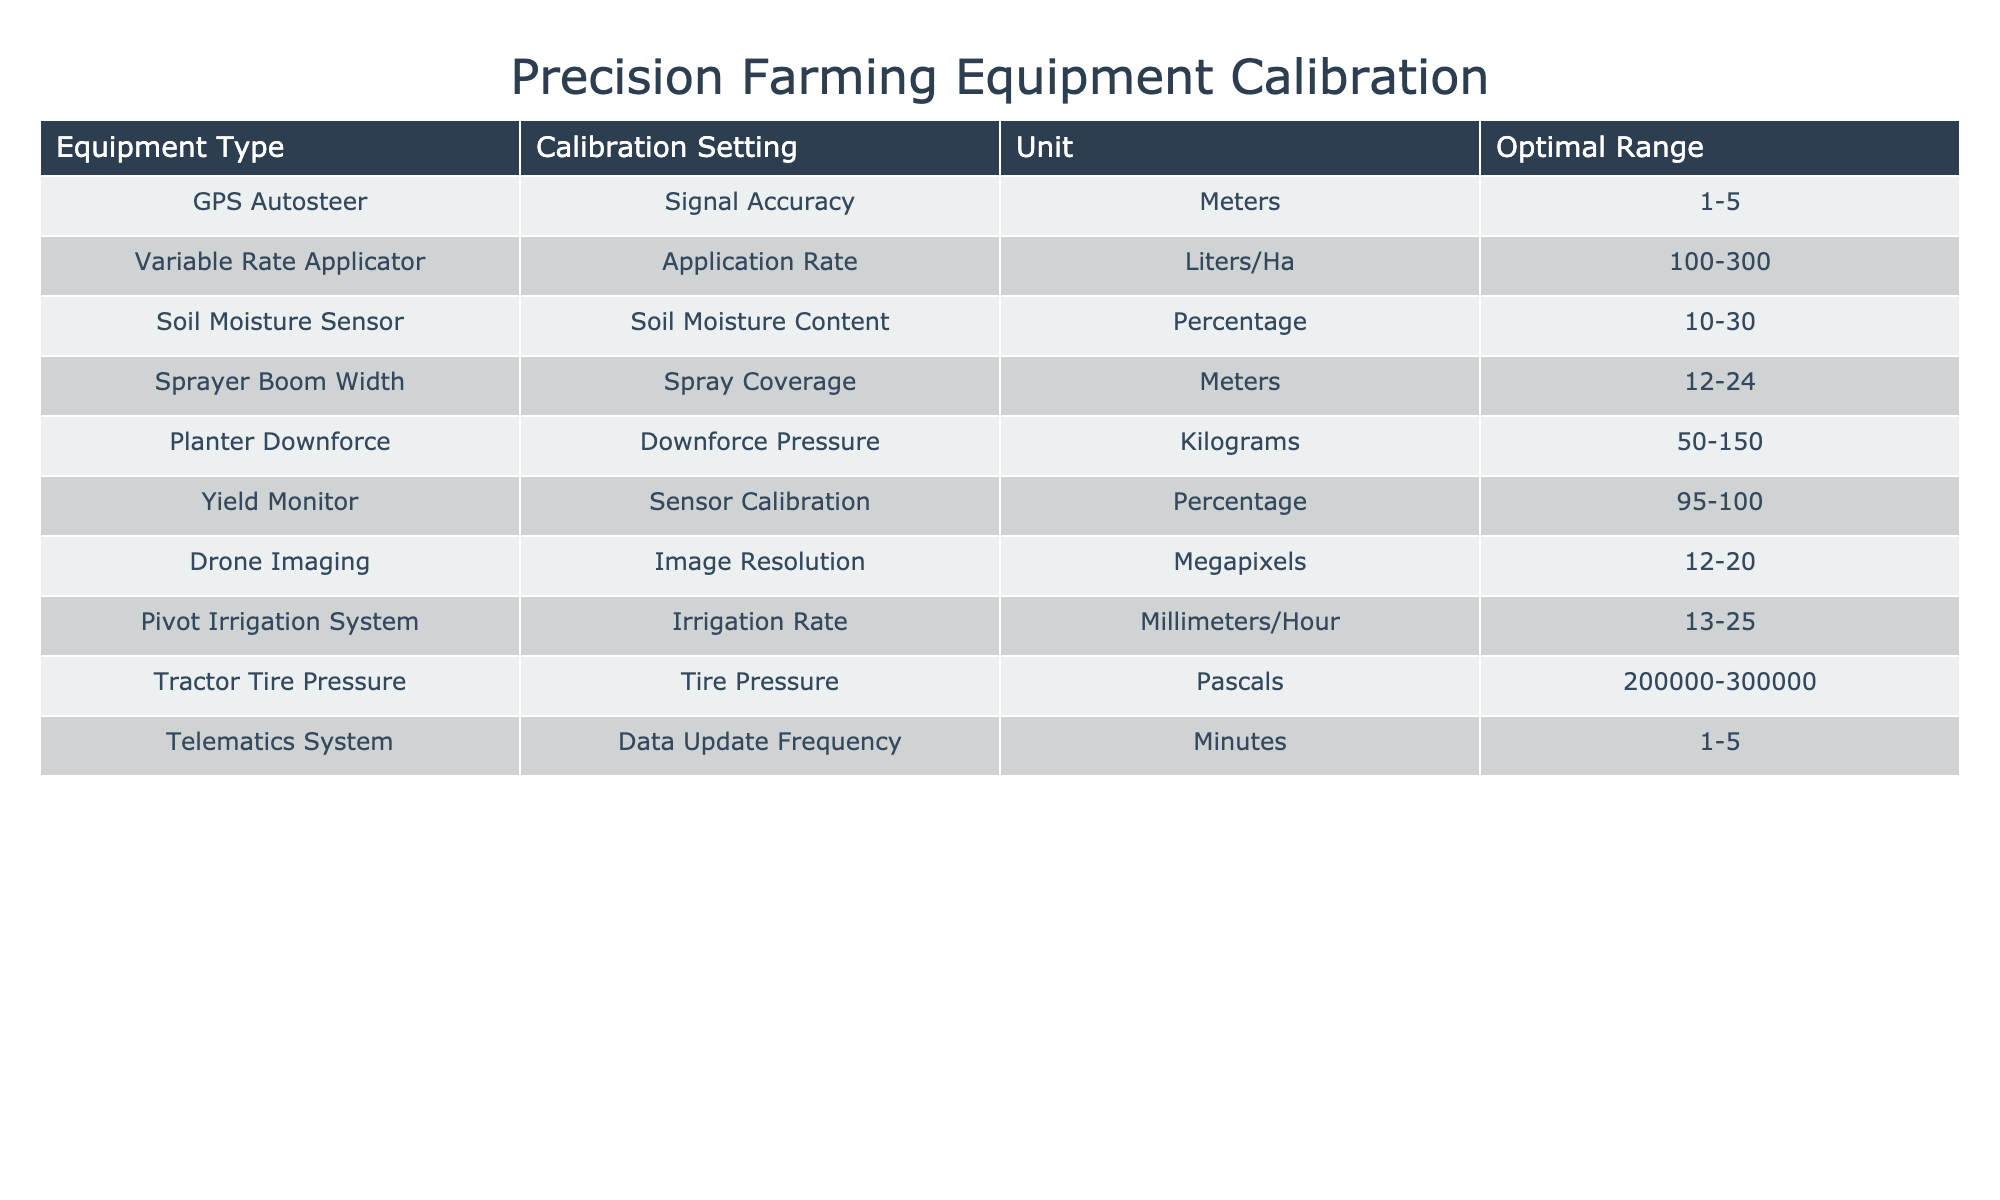What is the optimal range for the Soil Moisture Sensor? According to the table, the optimal range for the Soil Moisture Sensor is listed under the "Optimal Range" column. The value provided is "10-30".
Answer: 10-30 What is the Calibration Setting for the Variable Rate Applicator? Looking at the table, the Calibration Setting for the Variable Rate Applicator is found in that specific row under the "Calibration Setting" column, which states "Application Rate".
Answer: Application Rate Is the optimal irrigation rate for the Pivot Irrigation System higher than 20 millimeters per hour? By checking the "Optimal Range" column for the Pivot Irrigation System, we see it lists "13-25". The maximum value of 25 is indeed higher than 20.
Answer: Yes Which equipment has the highest optimal range for Calibration Settings? We need to identify the "Optimal Range" from all equipment types. The Soil Moisture Sensor has a range of "10-30", while the Pivot Irrigation System has "13-25". The Variable Rate Applicator has "100-300", which is the highest range.
Answer: Variable Rate Applicator What are the average optimal range values calculated for all equipment types? To calculate the average, we first convert the ranges to numerical values. For example, Soil Moisture ranges from 10 to 30 is (10+30)/2 = 20, Pivot Irrigation (13+25)/2 = 19, etc. If we sum up all averages and divide by the number of equipment types (10), we find the overall average.
Answer: Approximately 39.5 What is the Tire Pressure range for the Tractor? The "Optimal Range" for Tractor Tire Pressure listed in the table shows "200000-300000" Pascals.
Answer: 200000-300000 Do all equipment types provide a calibration setting that is represented in physical units? By reviewing the "Unit" column for each row, each listed Calibration Setting correlates with a specific unit of measure, indicating that all types do represent physical units.
Answer: Yes Which equipment type has the narrowest optimal range? By examining the "Optimal Range" column, we see that the Yield Monitor has a range listed as "95-100," which is 5 units wide, making it the narrowest.
Answer: Yield Monitor What Calibration Setting is used for Drone Imaging? The table lists "Image Resolution" under the "Calibration Setting" for Drone Imaging.
Answer: Image Resolution 